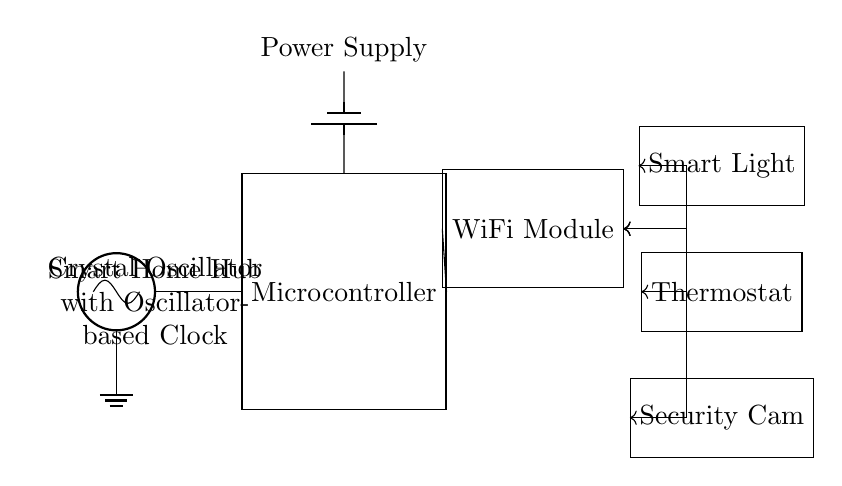What is the main component that generates the clock signal? The main component generating the clock signal is the crystal oscillator, which is indicated by the symbol labeled as "Crystal Oscillator" in the diagram.
Answer: Crystal Oscillator What is the role of the microcontroller in the circuit? The microcontroller's role is to process data and control the connected devices based on the clock signal it receives from the oscillator. It serves as the central processing unit for the smart home hub.
Answer: Control devices Which connected device is located at the top of the diagram? The connected device located at the top of the diagram is the Smart Light, as indicated by its position and label in the circuit.
Answer: Smart Light How is power supplied to the microcontroller? Power is supplied to the microcontroller through a battery, which is represented in the circuit diagram as a battery symbol connected to the north pin of the microcontroller.
Answer: Battery What type of communication is used to connect devices to the WiFi module? The devices are connected to the WiFi module using bidirectional communication, as indicated by the double-headed arrows connecting the WiFi module to each device.
Answer: Bidirectional What is the purpose of the WiFi module in the circuit? The WiFi module's purpose is to enable wireless communication between the connected devices and the smart home hub, allowing them to receive commands and send data.
Answer: Wireless communication How many connected devices are shown in the circuit? The circuit shows three connected devices, which are the Smart Light, Thermostat, and Security Cam arranged vertically.
Answer: Three 